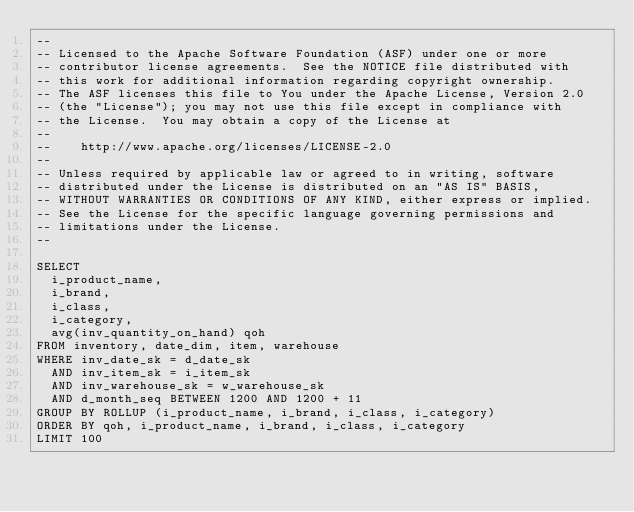<code> <loc_0><loc_0><loc_500><loc_500><_SQL_>--
-- Licensed to the Apache Software Foundation (ASF) under one or more
-- contributor license agreements.  See the NOTICE file distributed with
-- this work for additional information regarding copyright ownership.
-- The ASF licenses this file to You under the Apache License, Version 2.0
-- (the "License"); you may not use this file except in compliance with
-- the License.  You may obtain a copy of the License at
--
--    http://www.apache.org/licenses/LICENSE-2.0
--
-- Unless required by applicable law or agreed to in writing, software
-- distributed under the License is distributed on an "AS IS" BASIS,
-- WITHOUT WARRANTIES OR CONDITIONS OF ANY KIND, either express or implied.
-- See the License for the specific language governing permissions and
-- limitations under the License.
--

SELECT
  i_product_name,
  i_brand,
  i_class,
  i_category,
  avg(inv_quantity_on_hand) qoh
FROM inventory, date_dim, item, warehouse
WHERE inv_date_sk = d_date_sk
  AND inv_item_sk = i_item_sk
  AND inv_warehouse_sk = w_warehouse_sk
  AND d_month_seq BETWEEN 1200 AND 1200 + 11
GROUP BY ROLLUP (i_product_name, i_brand, i_class, i_category)
ORDER BY qoh, i_product_name, i_brand, i_class, i_category
LIMIT 100
</code> 